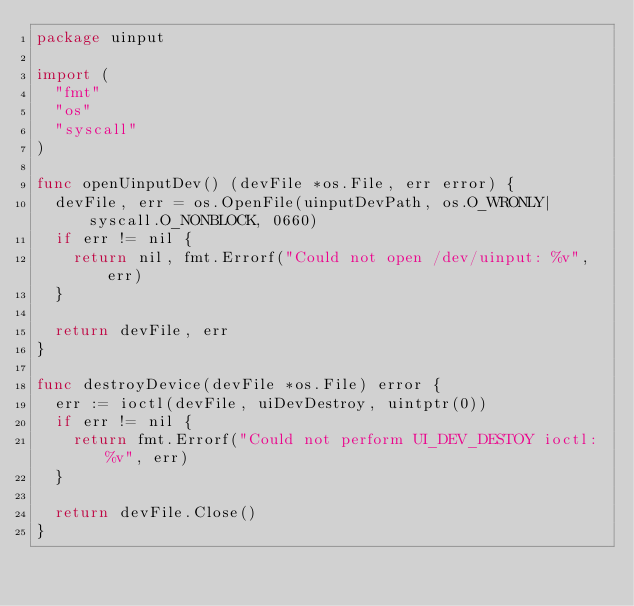<code> <loc_0><loc_0><loc_500><loc_500><_Go_>package uinput

import (
	"fmt"
	"os"
	"syscall"
)

func openUinputDev() (devFile *os.File, err error) {
	devFile, err = os.OpenFile(uinputDevPath, os.O_WRONLY|syscall.O_NONBLOCK, 0660)
	if err != nil {
		return nil, fmt.Errorf("Could not open /dev/uinput: %v", err)
	}

	return devFile, err
}

func destroyDevice(devFile *os.File) error {
	err := ioctl(devFile, uiDevDestroy, uintptr(0))
	if err != nil {
		return fmt.Errorf("Could not perform UI_DEV_DESTOY ioctl: %v", err)
	}

	return devFile.Close()
}
</code> 